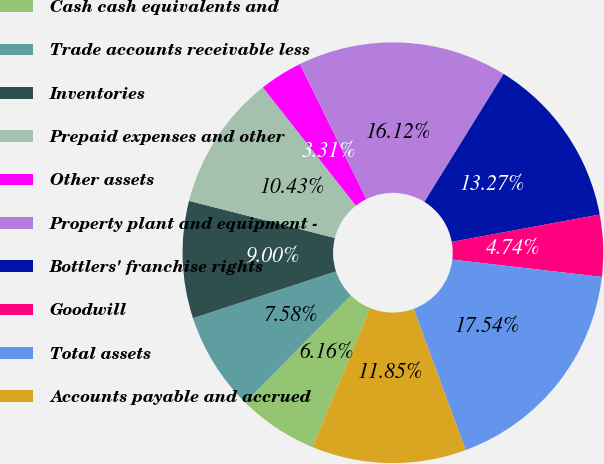<chart> <loc_0><loc_0><loc_500><loc_500><pie_chart><fcel>Cash cash equivalents and<fcel>Trade accounts receivable less<fcel>Inventories<fcel>Prepaid expenses and other<fcel>Other assets<fcel>Property plant and equipment -<fcel>Bottlers' franchise rights<fcel>Goodwill<fcel>Total assets<fcel>Accounts payable and accrued<nl><fcel>6.16%<fcel>7.58%<fcel>9.0%<fcel>10.43%<fcel>3.31%<fcel>16.12%<fcel>13.27%<fcel>4.74%<fcel>17.54%<fcel>11.85%<nl></chart> 